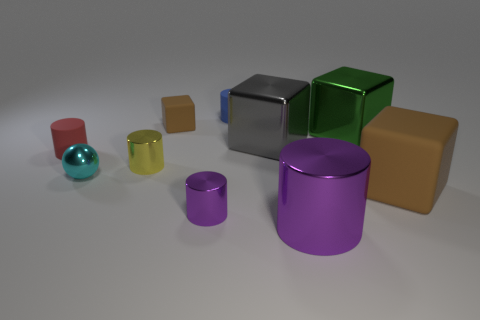There is a big gray object; is its shape the same as the purple shiny object on the right side of the small purple thing?
Ensure brevity in your answer.  No. What number of cylinders are small metal things or red things?
Your answer should be compact. 3. What is the color of the shiny sphere?
Ensure brevity in your answer.  Cyan. Is the number of small purple metal objects greater than the number of big gray rubber objects?
Provide a short and direct response. Yes. How many objects are either metallic cylinders in front of the cyan shiny object or brown things?
Your response must be concise. 4. Is the cyan ball made of the same material as the green block?
Keep it short and to the point. Yes. The other brown thing that is the same shape as the tiny brown thing is what size?
Your response must be concise. Large. There is a big shiny thing behind the gray metallic block; is it the same shape as the brown object in front of the cyan sphere?
Your response must be concise. Yes. There is a cyan metallic thing; is it the same size as the purple object that is behind the large purple shiny object?
Provide a short and direct response. Yes. How many other objects are the same material as the tiny purple object?
Your answer should be compact. 5. 